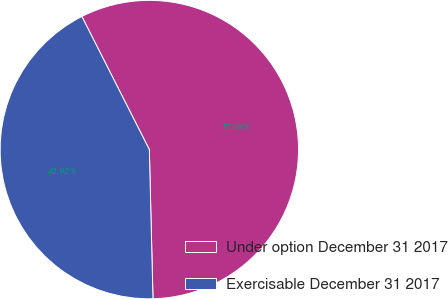Convert chart. <chart><loc_0><loc_0><loc_500><loc_500><pie_chart><fcel>Under option December 31 2017<fcel>Exercisable December 31 2017<nl><fcel>57.08%<fcel>42.92%<nl></chart> 